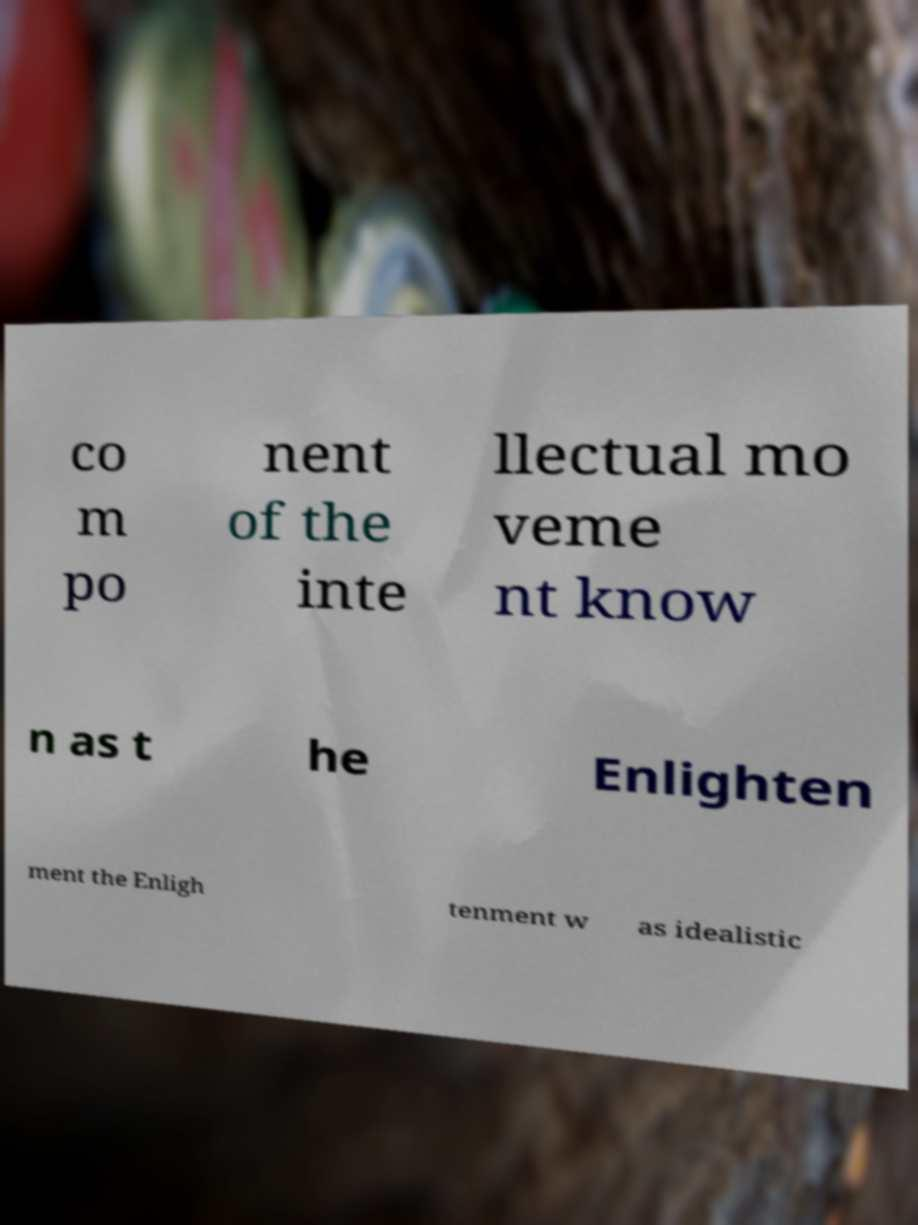There's text embedded in this image that I need extracted. Can you transcribe it verbatim? co m po nent of the inte llectual mo veme nt know n as t he Enlighten ment the Enligh tenment w as idealistic 